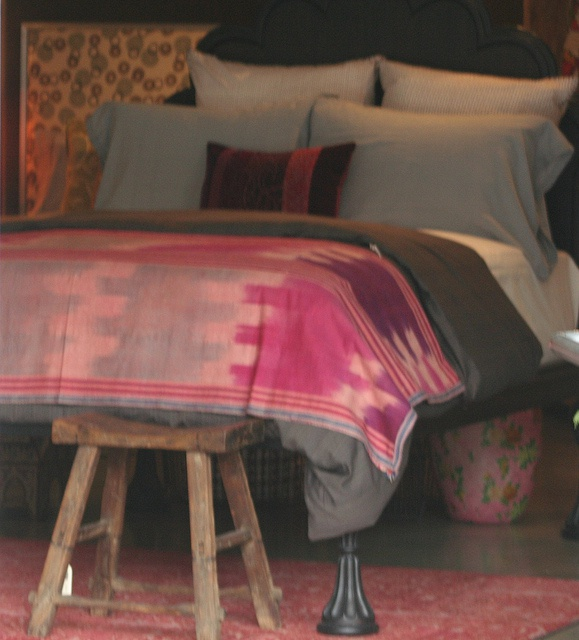Describe the objects in this image and their specific colors. I can see bed in gray, brown, black, and maroon tones, chair in gray, brown, black, and tan tones, and vase in gray, maroon, brown, and black tones in this image. 